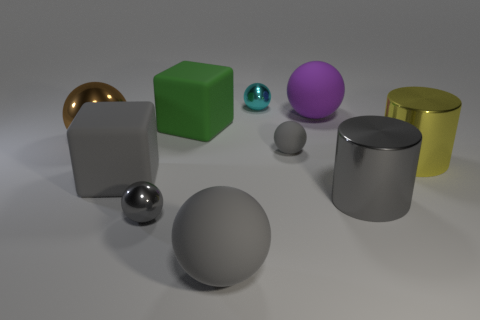Is the small rubber sphere the same color as the big metallic ball?
Your answer should be compact. No. Are there more gray objects than metal cylinders?
Provide a succinct answer. Yes. There is a metallic thing that is behind the brown thing; is it the same shape as the large gray metallic object?
Make the answer very short. No. What number of tiny balls are in front of the large shiny sphere and behind the gray block?
Make the answer very short. 1. How many other big things are the same shape as the big green rubber object?
Your answer should be compact. 1. What is the color of the small shiny thing that is left of the big gray matte object right of the gray cube?
Offer a terse response. Gray. Is the shape of the large yellow thing the same as the tiny thing that is behind the purple matte ball?
Your answer should be very brief. No. What is the material of the yellow cylinder in front of the tiny gray matte thing on the right side of the small metallic thing behind the large yellow cylinder?
Your answer should be very brief. Metal. Are there any gray matte spheres that have the same size as the gray rubber cube?
Offer a very short reply. Yes. The purple sphere that is the same material as the big green cube is what size?
Your answer should be compact. Large. 